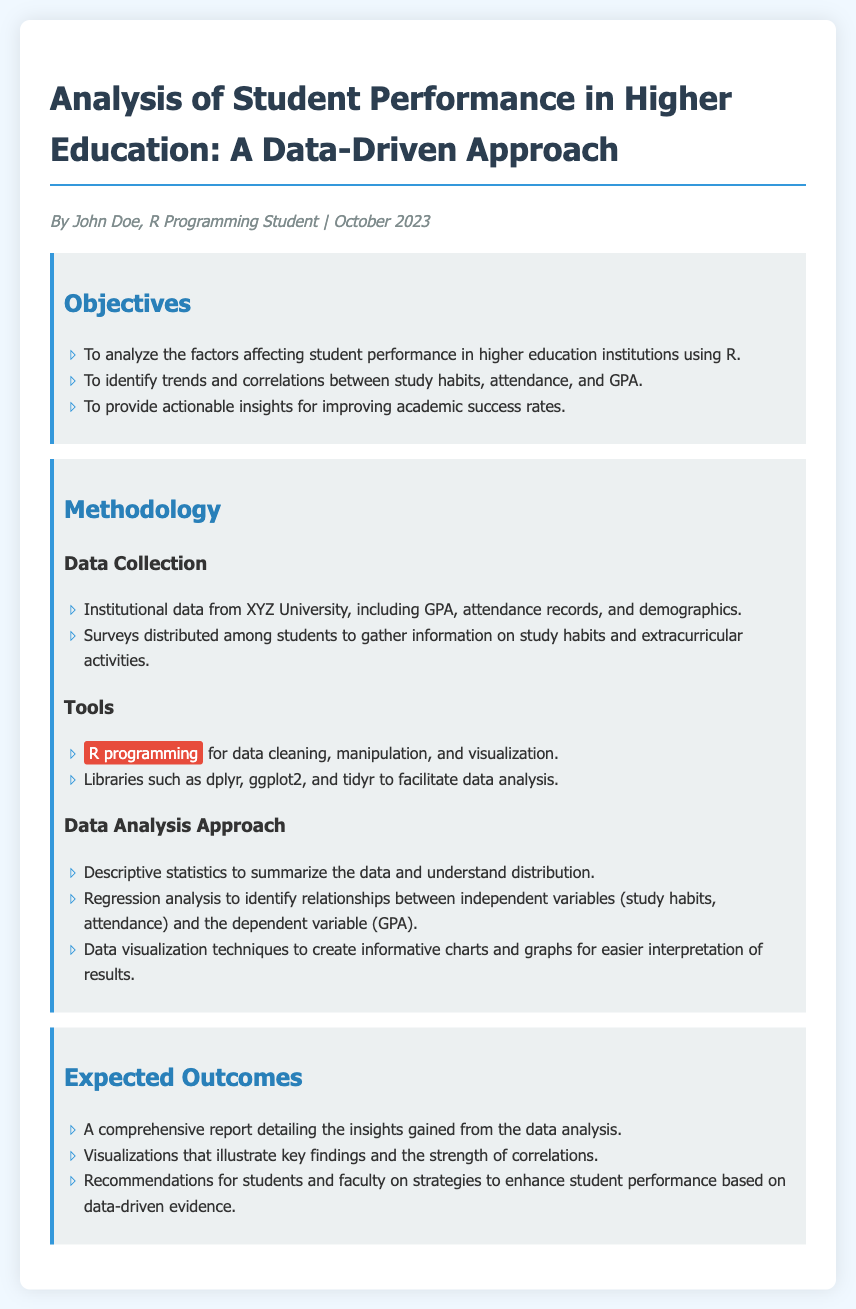What is the title of the project proposal? The title is the header of the memo that indicates the project focus.
Answer: Analysis of Student Performance in Higher Education: A Data-Driven Approach Who is the author of the memo? The author is named in the author-date section of the memo, indicating who wrote it.
Answer: John Doe What is the main tool used for data analysis? The memo mentions a specific programming language used for analysis in the methodology section.
Answer: R programming What type of analysis will be used to identify relationships in the data? The methodology section describes a specific type of analysis focused on relationships between variables.
Answer: Regression analysis What is one objective of the project? One of the primary goals is listed in the objectives section that focuses on analyzing performance factors.
Answer: To analyze the factors affecting student performance in higher education institutions using R What type of data collection method will be used? The methodology discusses how data will be gathered, pointing out specific strategies described in that section.
Answer: Surveys How many expected outcomes are listed in the memo? The expected outcomes section outlines specific results anticipated from the analysis.
Answer: Three Which library is specifically highlighted for use in data visualization? The methodology section mentions specific libraries, with one being emphasized for visualization purposes.
Answer: ggplot2 What demographic data will be collected from students? The data collection section describes general information that will be gathered regarding the student population.
Answer: Demographics 